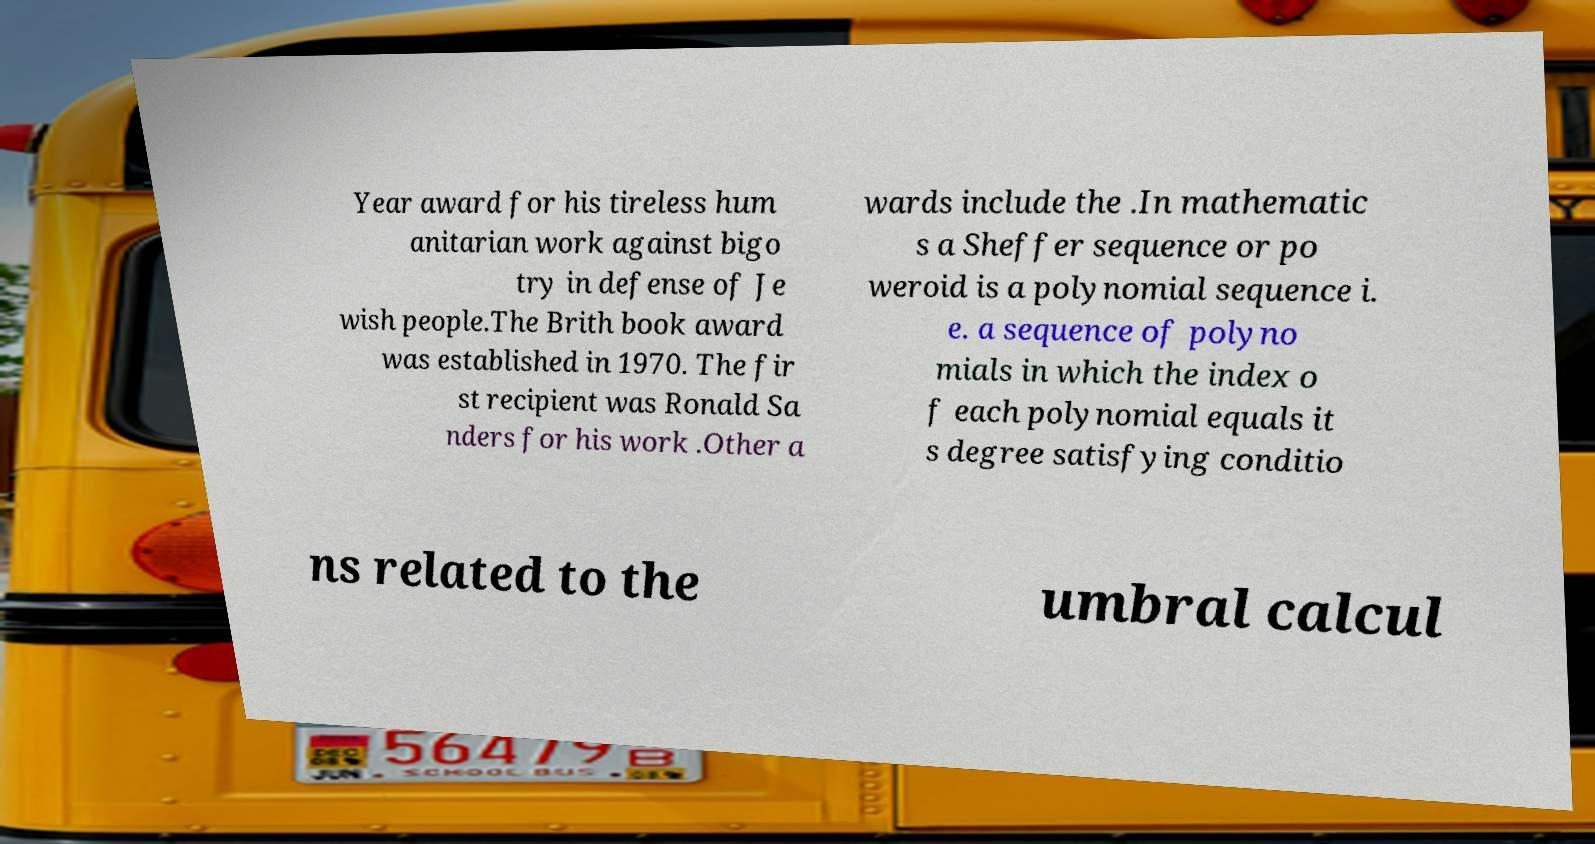Please identify and transcribe the text found in this image. Year award for his tireless hum anitarian work against bigo try in defense of Je wish people.The Brith book award was established in 1970. The fir st recipient was Ronald Sa nders for his work .Other a wards include the .In mathematic s a Sheffer sequence or po weroid is a polynomial sequence i. e. a sequence of polyno mials in which the index o f each polynomial equals it s degree satisfying conditio ns related to the umbral calcul 